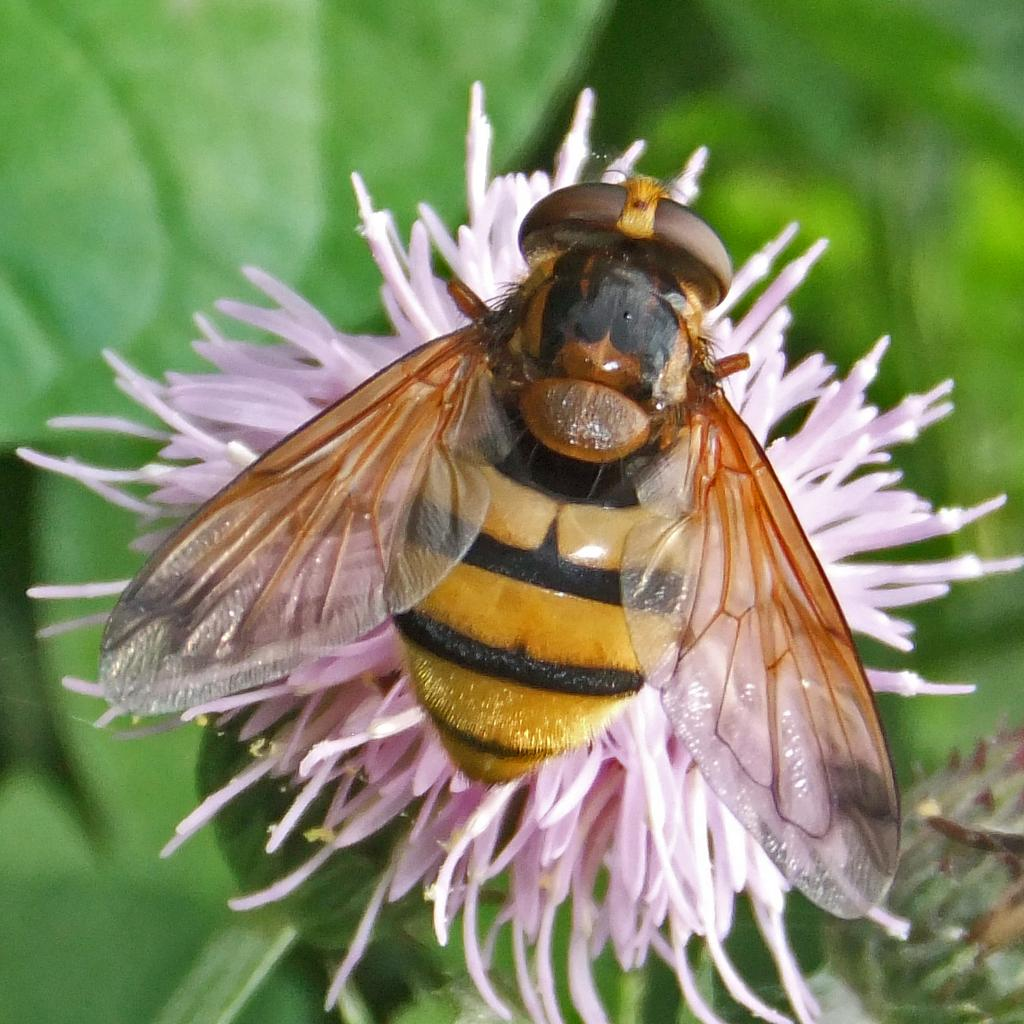What is the main subject of the image? There is an insect in the image. Where is the insect located? The insect is on a flower. Can you describe the background of the image? The background of the image is blurred. What type of cheese is being served at the insect's birthday party in the image? There is no cheese or birthday party present in the image; it features an insect on a flower with a blurred background. 